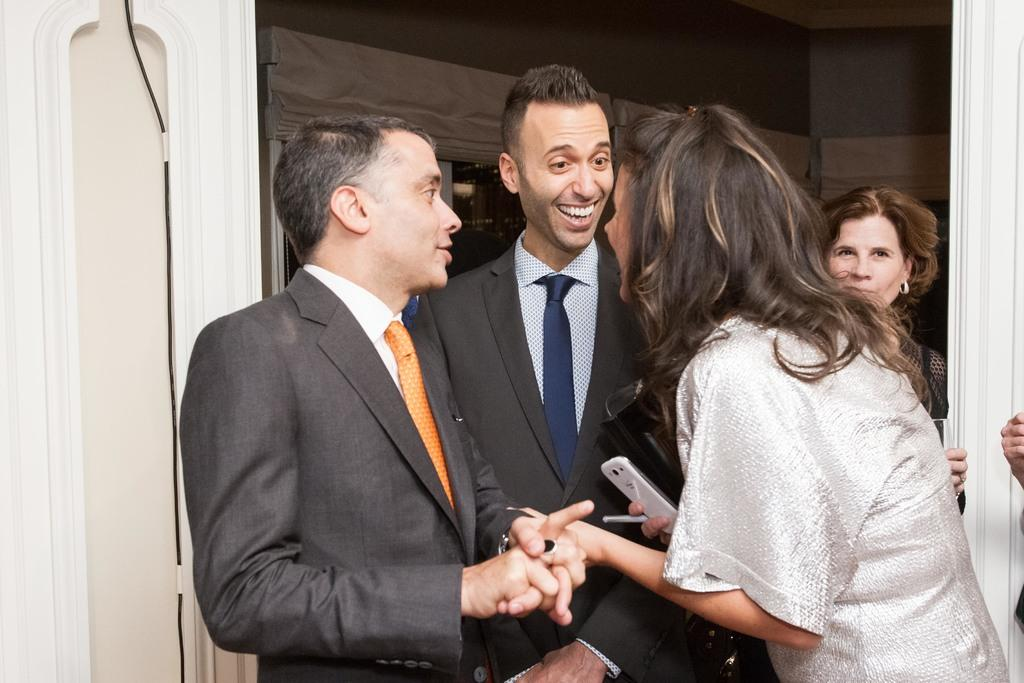Who or what can be seen in the image? There are people in the image. What type of structures are present in the image? There are walls in the image. Are there any window treatments visible in the image? Yes, there are curtains in the image. What architectural feature is present in the image? There is a window in the image. What are the people holding in the image? The people are holding objects. What type of hair can be seen on the people in the image? There is no mention of hair in the provided facts, so it cannot be determined from the image. 